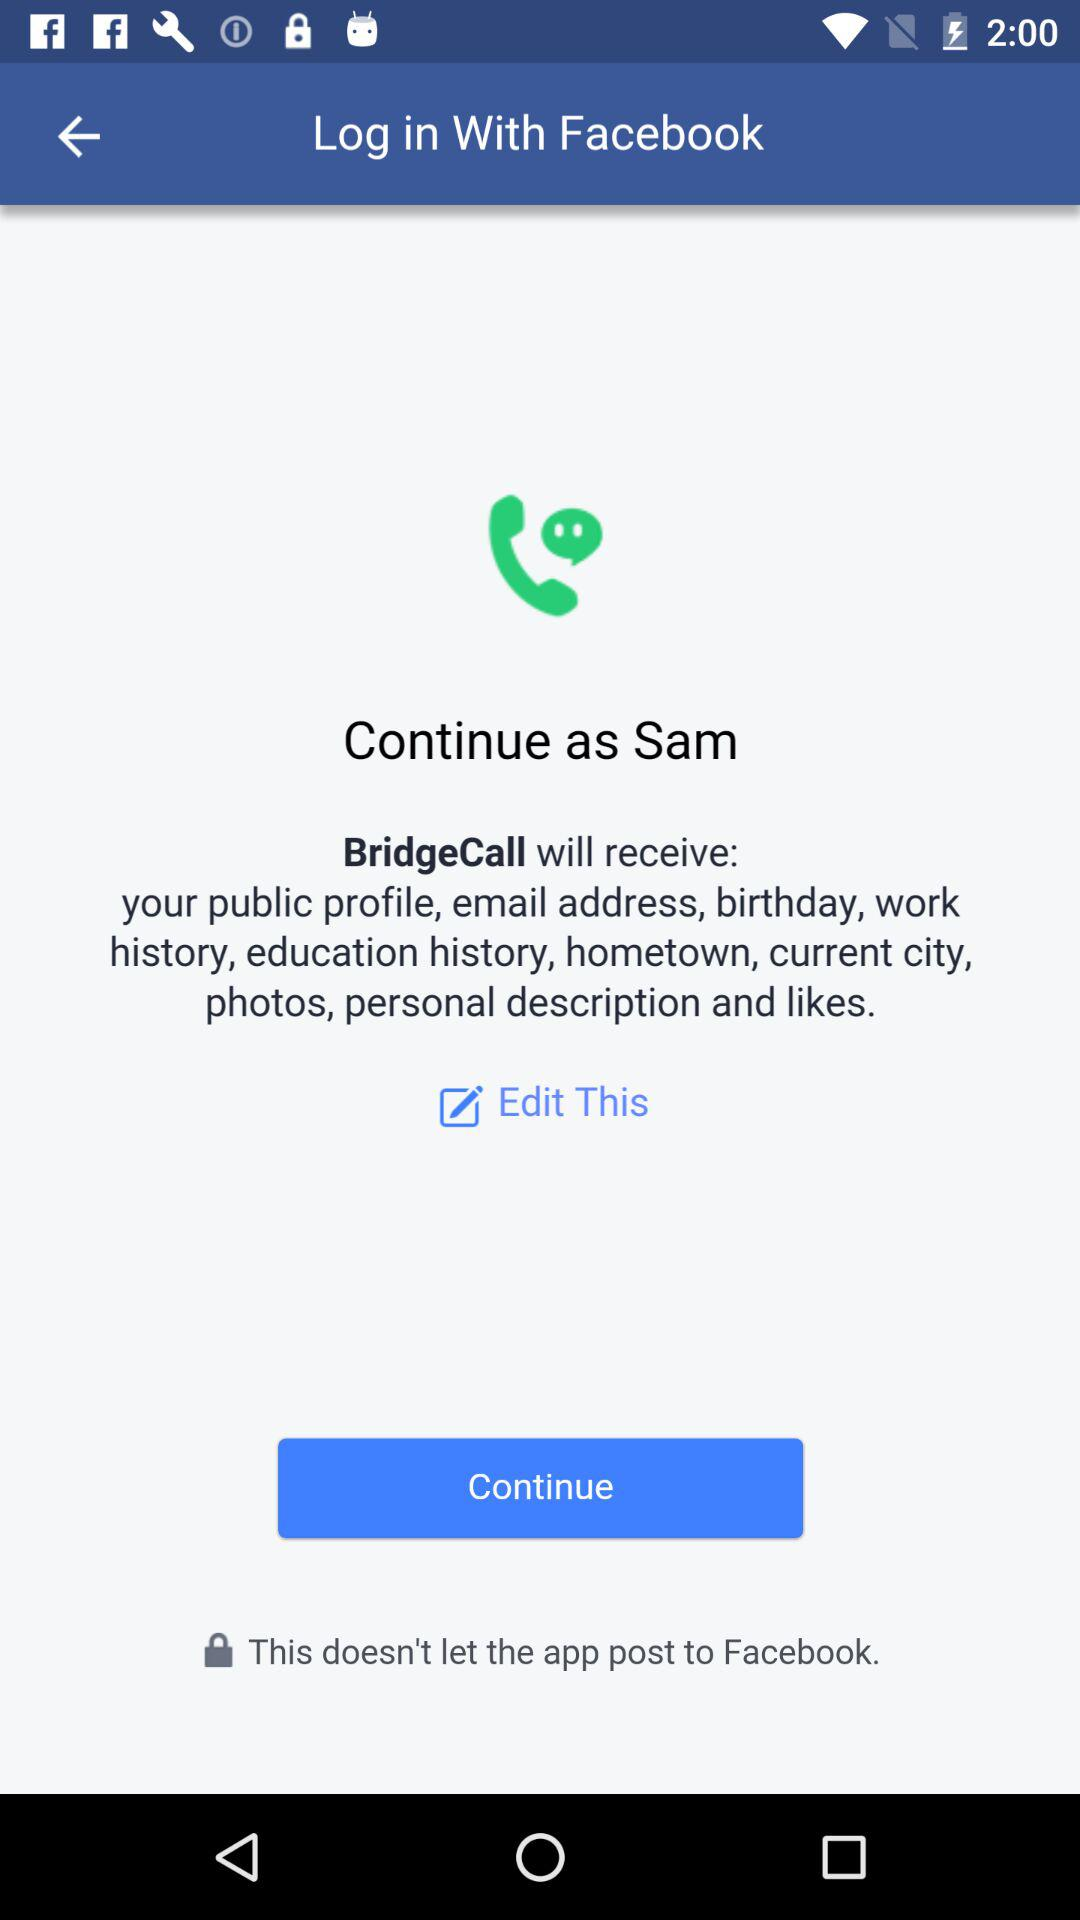What is the name of the user? The name of the user is Sam. 